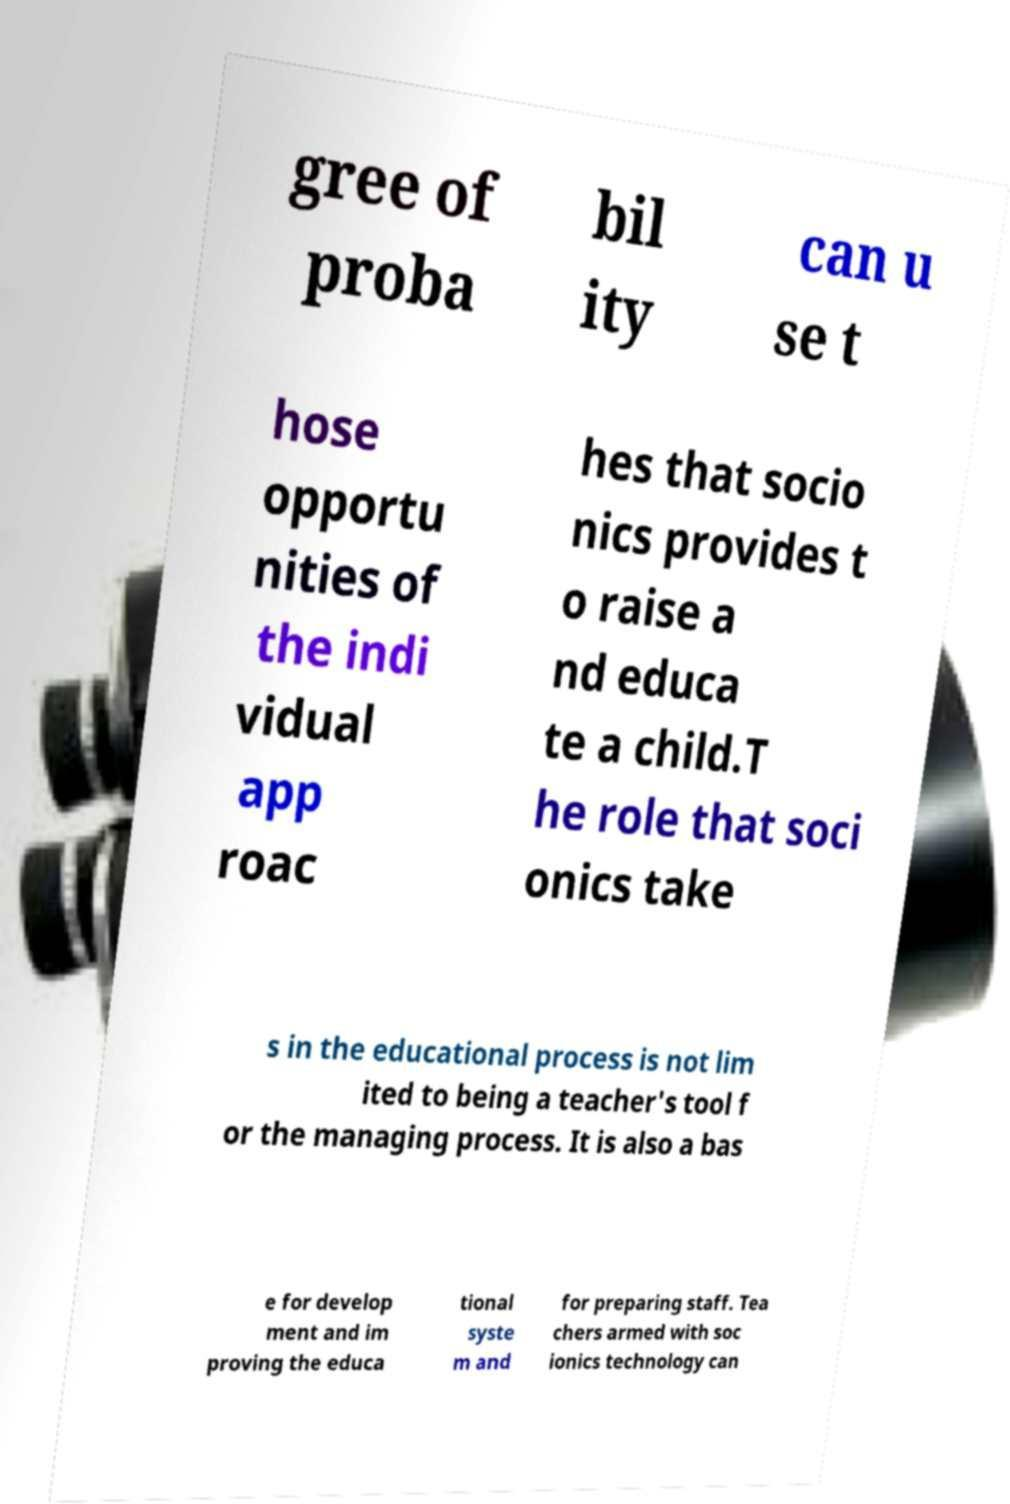Please read and relay the text visible in this image. What does it say? gree of proba bil ity can u se t hose opportu nities of the indi vidual app roac hes that socio nics provides t o raise a nd educa te a child.T he role that soci onics take s in the educational process is not lim ited to being a teacher's tool f or the managing process. It is also a bas e for develop ment and im proving the educa tional syste m and for preparing staff. Tea chers armed with soc ionics technology can 